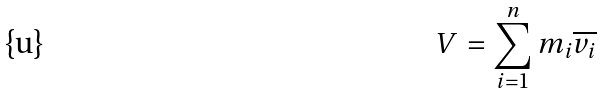Convert formula to latex. <formula><loc_0><loc_0><loc_500><loc_500>V = \sum _ { i = 1 } ^ { n } m _ { i } \overline { v _ { i } }</formula> 